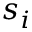Convert formula to latex. <formula><loc_0><loc_0><loc_500><loc_500>s _ { i }</formula> 